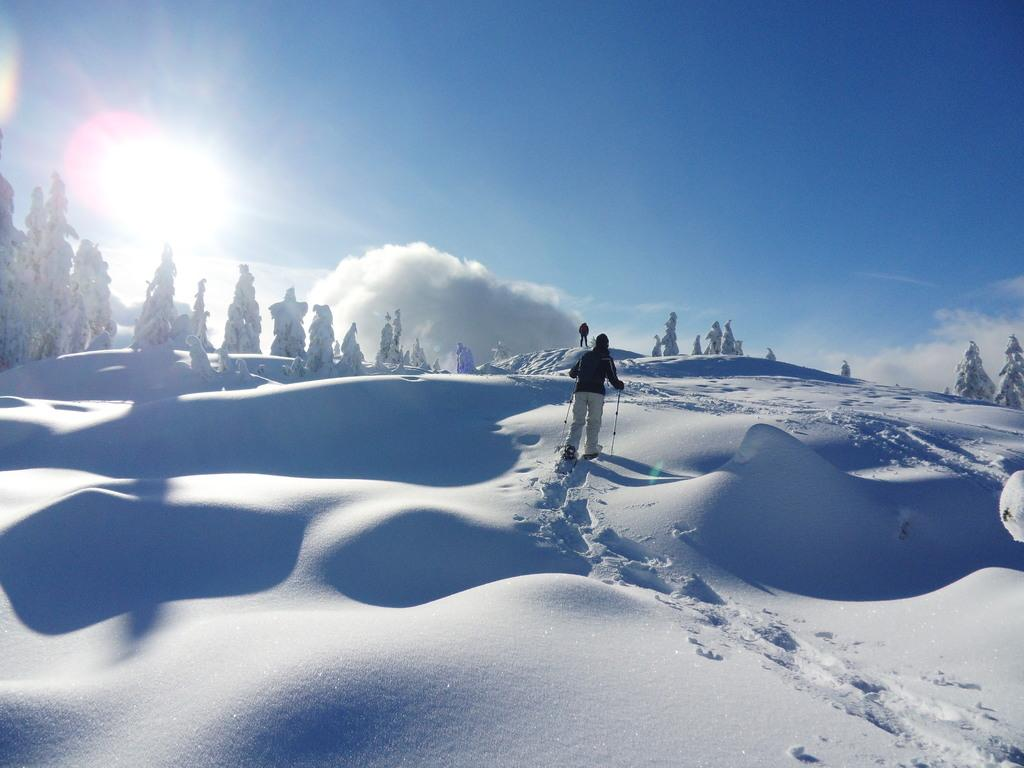What is the surface that the people are standing on in the image? The people are standing on the snow in the image. What can be seen in the background of the image? There are trees and the sky visible in the background of the image. What is the condition of the sky in the image? The sky has clouds and the sun is visible in the image. What type of cap can be seen on the bone in the image? There is no cap or bone present in the image; it features people standing on snow with trees, clouds, and the sun visible in the sky. 